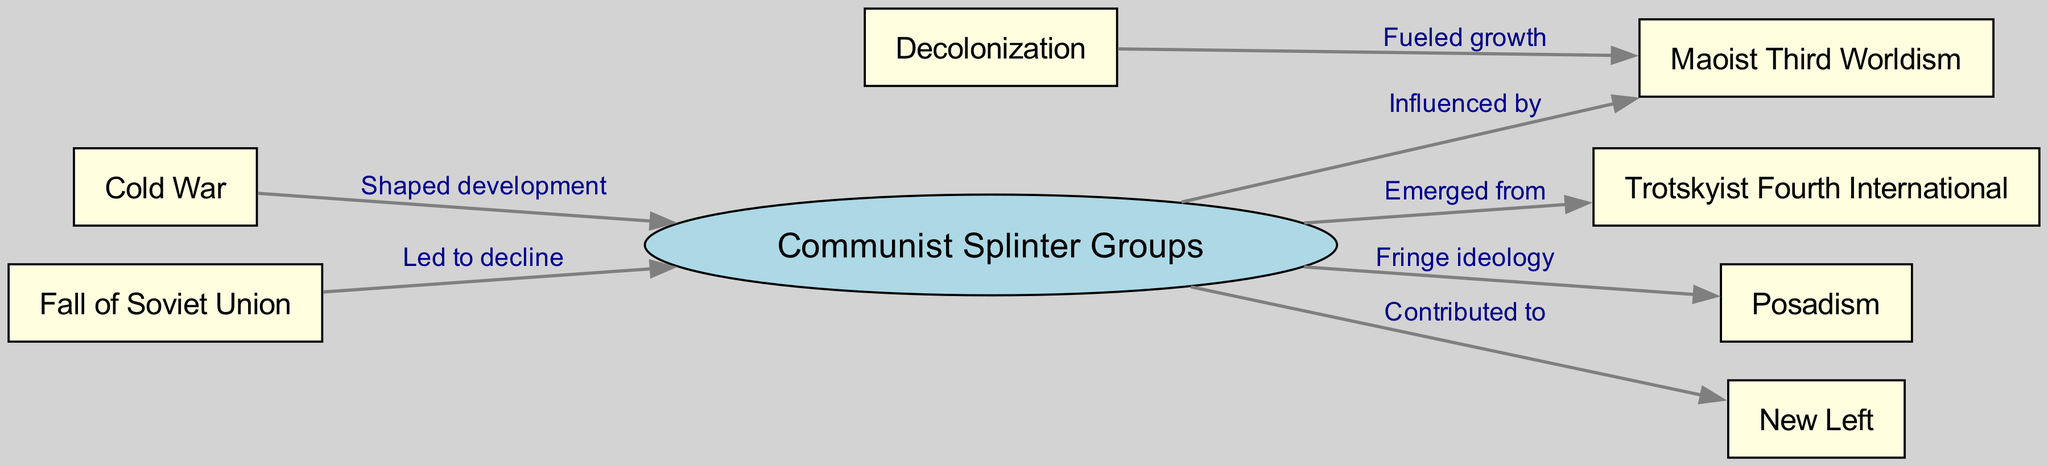What is the central node in the diagram? The central node is highlighted visually with an ellipse shape and labeled clearly as "Communist Splinter Groups," indicating it is the primary focus of the diagram.
Answer: Communist Splinter Groups How many nodes are present in the diagram? By counting each unique item listed in the nodes section of the diagram, we find there are 8 nodes total.
Answer: 8 Which splinter group emerged from the central node? The edge labeled "Emerged from" directly connects the central node 'Communist Splinter Groups' to the node 'Trotskyist Fourth International,' indicating this relationship.
Answer: Trotskyist Fourth International What ideology is classified as a fringe belief among the groups? The edge labeled "Fringe ideology" points to the node 'Posadism,' indicating it is recognized as a fringe ideology among the communist splinter groups.
Answer: Posadism Which major global event shaped the development of communist splinter groups? The edge labeled "Shaped development" connects the 'Cold War' node to the central node 'Communist Splinter Groups,' signifying its influence on the emergence and evolution of these groups.
Answer: Cold War How did decolonization influence Maoist Third Worldism? The edge labeled "Fueled growth" connects the node 'Decolonization' to 'Maoist Third Worldism,' indicating that this global shift positively impacted the development of Maoist ideology.
Answer: Fueled growth What led to the decline of the communist splinter groups? The edge labeled "Led to decline" connects 'Fall of Soviet Union' to 'Communist Splinter Groups,' clearly indicating that this event was a contributing factor to their decrease in influence.
Answer: Fall of Soviet Union Which group contributed to the New Left? The edge labeled "Contributed to" connects the central node 'Communist Splinter Groups' to the node 'New Left,' suggesting that these groups played a role in its formation and ideologies.
Answer: New Left 